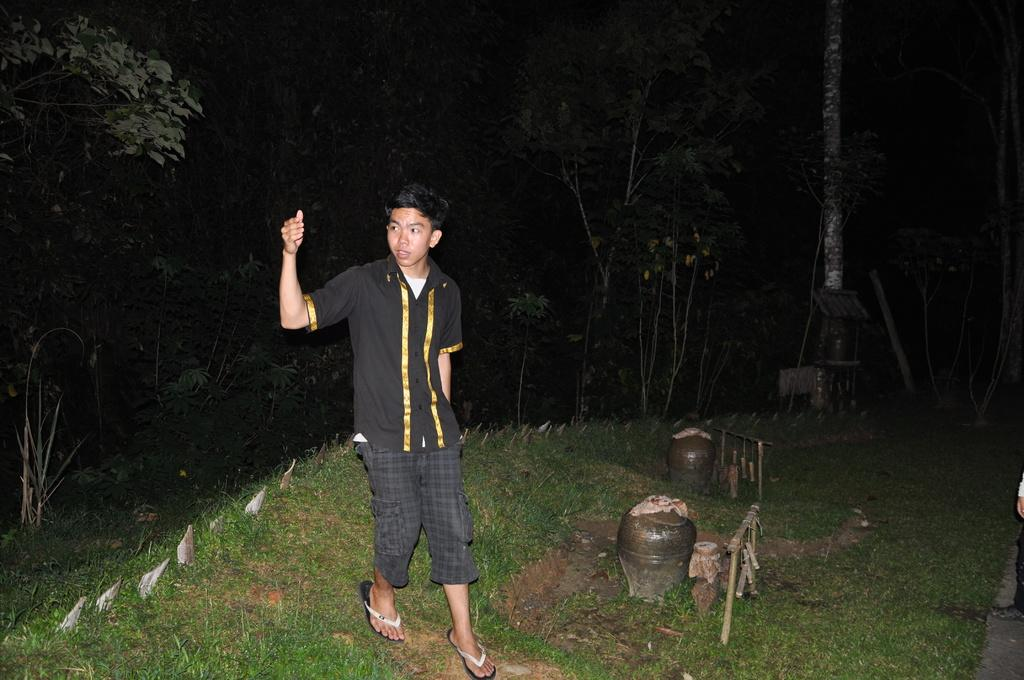What is the person in the image doing? There is a person walking in the image. What type of surface is the person walking on? There is grass on the ground in the image. What else can be seen in the image besides the person walking? There are objects and trees in the background of the image. Can you describe the background of the image? There are trees and a pole in the background of the image. What is the mass of the person's sister in the image? There is no mention of a sister in the image, so it is impossible to determine the mass of a nonexistent person. 